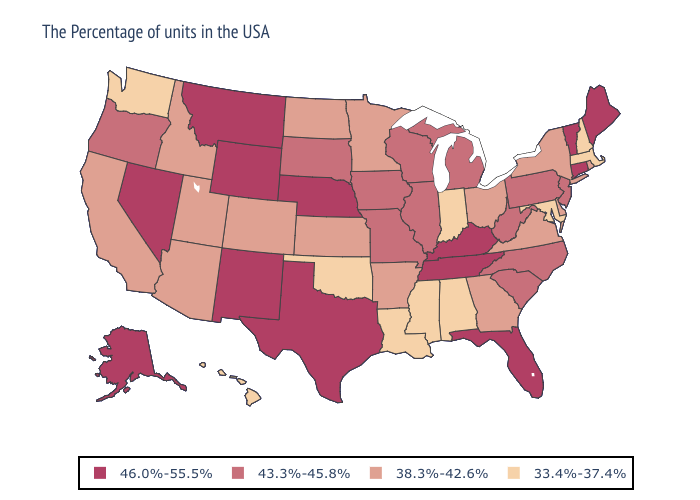What is the value of Idaho?
Be succinct. 38.3%-42.6%. Name the states that have a value in the range 38.3%-42.6%?
Quick response, please. Rhode Island, New York, Delaware, Virginia, Ohio, Georgia, Arkansas, Minnesota, Kansas, North Dakota, Colorado, Utah, Arizona, Idaho, California. What is the lowest value in states that border Florida?
Quick response, please. 33.4%-37.4%. Among the states that border Oregon , does Idaho have the lowest value?
Answer briefly. No. Name the states that have a value in the range 43.3%-45.8%?
Keep it brief. New Jersey, Pennsylvania, North Carolina, South Carolina, West Virginia, Michigan, Wisconsin, Illinois, Missouri, Iowa, South Dakota, Oregon. What is the value of Texas?
Quick response, please. 46.0%-55.5%. What is the value of Virginia?
Be succinct. 38.3%-42.6%. What is the value of New Jersey?
Concise answer only. 43.3%-45.8%. Name the states that have a value in the range 43.3%-45.8%?
Be succinct. New Jersey, Pennsylvania, North Carolina, South Carolina, West Virginia, Michigan, Wisconsin, Illinois, Missouri, Iowa, South Dakota, Oregon. Does Nevada have the same value as Utah?
Give a very brief answer. No. Which states have the lowest value in the USA?
Keep it brief. Massachusetts, New Hampshire, Maryland, Indiana, Alabama, Mississippi, Louisiana, Oklahoma, Washington, Hawaii. Which states have the highest value in the USA?
Be succinct. Maine, Vermont, Connecticut, Florida, Kentucky, Tennessee, Nebraska, Texas, Wyoming, New Mexico, Montana, Nevada, Alaska. What is the highest value in the USA?
Be succinct. 46.0%-55.5%. What is the lowest value in states that border Texas?
Short answer required. 33.4%-37.4%. What is the value of Colorado?
Write a very short answer. 38.3%-42.6%. 